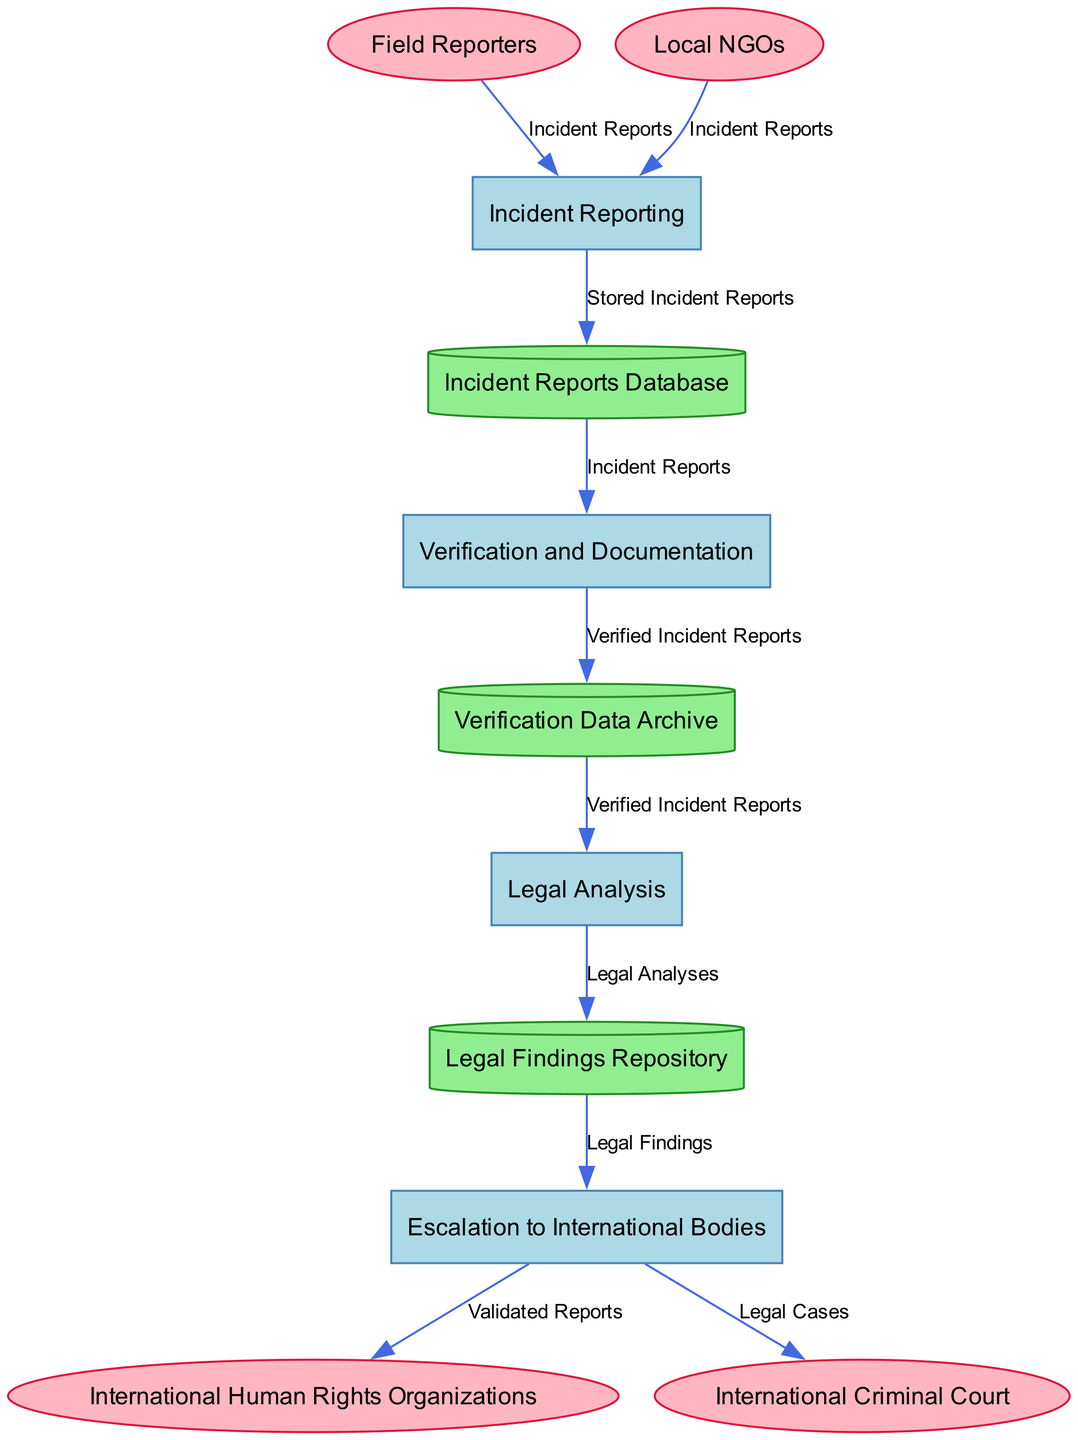What is the first process in the diagram? The first process listed in the diagram is "Incident Reporting." It is the initial stage where reports of human rights violations are collected.
Answer: Incident Reporting How many data stores are present in the diagram? The diagram includes three data stores: "Incident Reports Database," "Verification Data Archive," and "Legal Findings Repository." Thus, the total count is three.
Answer: 3 What type of entity is "Local NGOs"? "Local NGOs" is categorized as an external entity in the diagram, indicated by its shape as an ellipse.
Answer: External Entity Which process stores verified and documented data? The process that stores verified data is "Verification and Documentation." After verification, the data is stored in the "Verification Data Archive."
Answer: Verification and Documentation What connects the "Incident Reports Database" to the "Verification and Documentation" process? The connection is made through data flow labeled "Incident Reports," which indicates the transfer of stored reports for verification.
Answer: Incident Reports Which external entity receives validated reports? The external entity that receives validated reports is "International Human Rights Organizations," to which reports are escalated after verification and legal analysis.
Answer: International Human Rights Organizations How many processes lead to the "Legal Findings Repository"? Two processes lead to the "Legal Findings Repository": "Legal Analysis," which sends data for storage, and "Escalation to International Bodies," which retrieves legal findings for escalation. The first is a single directed flow, and the latter retrieves findings for escalation. So, it is one direct process.
Answer: 1 Which data flow originates from "Field Reporters"? The data flow that originates from "Field Reporters" is titled "Incident Reports," which consists of the initial reports they send to the "Incident Reporting" process.
Answer: Incident Reports What document type is stored in the "Legal Findings Repository"? The type of document stored in the "Legal Findings Repository" is "Legal Analyses," which contains findings from the legal analysis of verified incidents.
Answer: Legal Analyses 